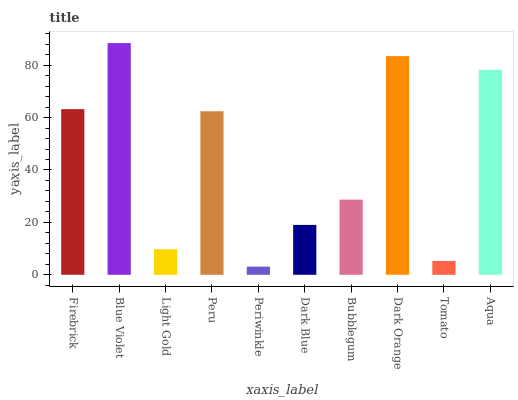Is Periwinkle the minimum?
Answer yes or no. Yes. Is Blue Violet the maximum?
Answer yes or no. Yes. Is Light Gold the minimum?
Answer yes or no. No. Is Light Gold the maximum?
Answer yes or no. No. Is Blue Violet greater than Light Gold?
Answer yes or no. Yes. Is Light Gold less than Blue Violet?
Answer yes or no. Yes. Is Light Gold greater than Blue Violet?
Answer yes or no. No. Is Blue Violet less than Light Gold?
Answer yes or no. No. Is Peru the high median?
Answer yes or no. Yes. Is Bubblegum the low median?
Answer yes or no. Yes. Is Tomato the high median?
Answer yes or no. No. Is Tomato the low median?
Answer yes or no. No. 